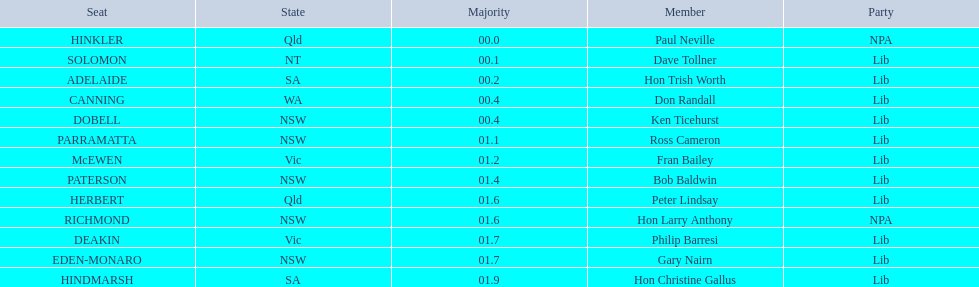Which chairs are featured in the australian electoral scheme? HINKLER, SOLOMON, ADELAIDE, CANNING, DOBELL, PARRAMATTA, McEWEN, PATERSON, HERBERT, RICHMOND, DEAKIN, EDEN-MONARO, HINDMARSH. What were the predominant numbers for hindmarsh and hinkler? HINKLER, HINDMARSH. What is the difference in majority votes between the two? 01.9. 